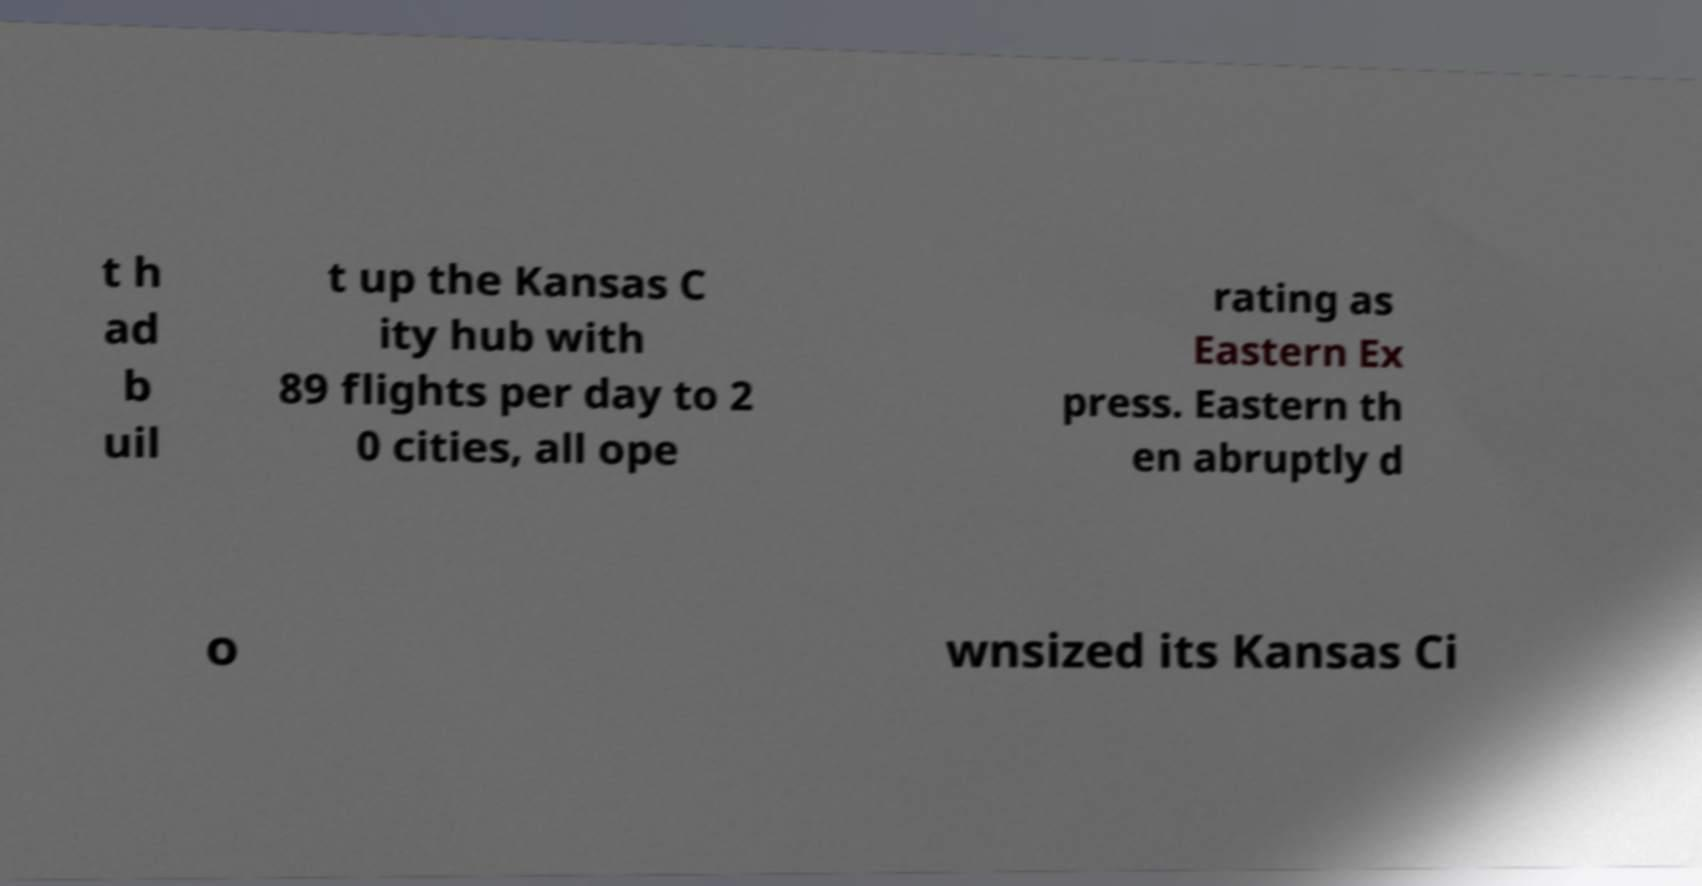There's text embedded in this image that I need extracted. Can you transcribe it verbatim? t h ad b uil t up the Kansas C ity hub with 89 flights per day to 2 0 cities, all ope rating as Eastern Ex press. Eastern th en abruptly d o wnsized its Kansas Ci 